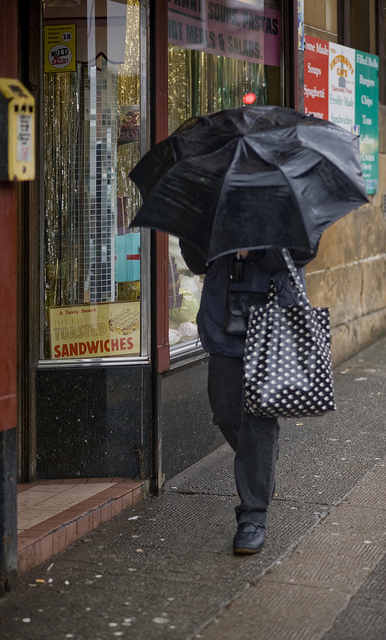Read and extract the text from this image. TOASTED SANDWICHES SALADS PASIAS 